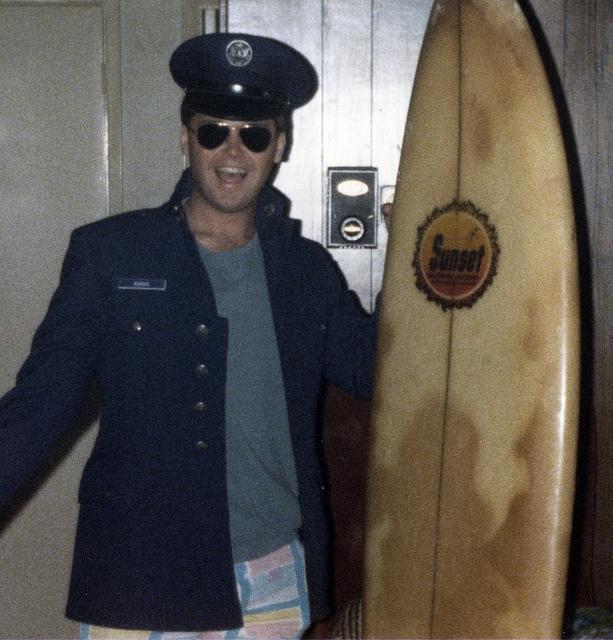Where is sunset?
Give a very brief answer. On surfboard. What type of sporting equipment is this person holding?
Keep it brief. Surfboard. What type of sunglasses is the man wearing?
Give a very brief answer. Aviators. 